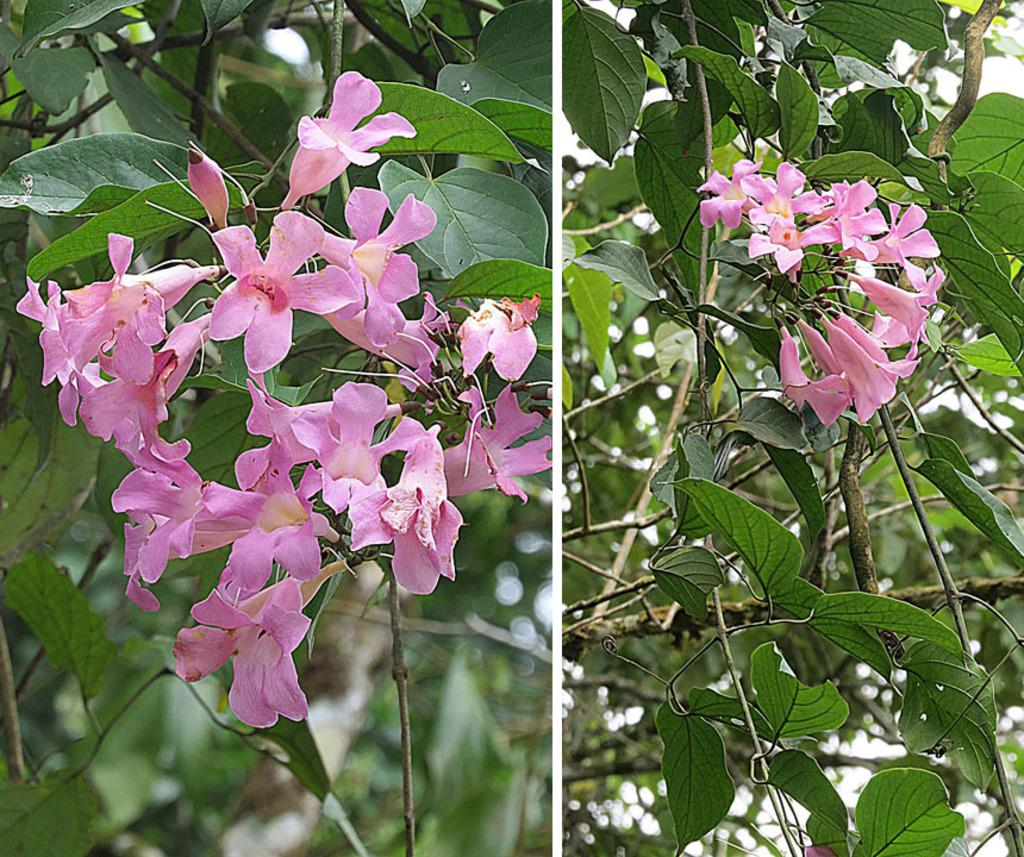How many images are present in the picture? There are two images in the picture. What types of vegetation can be seen in the images? Plants, flowers, and trees are present in the images. What type of humor can be seen in the images? There is no humor present in the images; they depict vegetation such as plants, flowers, and trees. 